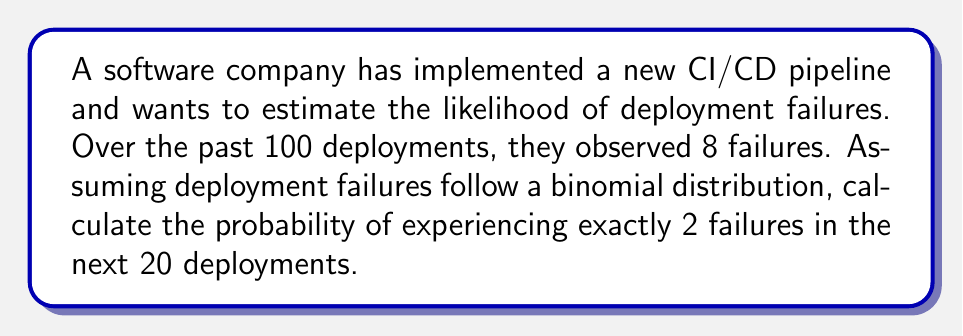Could you help me with this problem? To solve this problem, we'll use the binomial probability formula:

$$P(X = k) = \binom{n}{k} p^k (1-p)^{n-k}$$

Where:
- $n$ is the number of trials (deployments)
- $k$ is the number of successes (failures in this case)
- $p$ is the probability of success on a single trial

Step 1: Calculate the probability of failure ($p$) based on historical data
$p = \frac{\text{number of failures}}{\text{total deployments}} = \frac{8}{100} = 0.08$

Step 2: Identify the values for our scenario
- $n = 20$ (next 20 deployments)
- $k = 2$ (exactly 2 failures)
- $p = 0.08$ (calculated in step 1)

Step 3: Calculate the binomial coefficient
$$\binom{20}{2} = \frac{20!}{2!(20-2)!} = \frac{20!}{2!(18)!} = 190$$

Step 4: Apply the binomial probability formula
$$P(X = 2) = \binom{20}{2} (0.08)^2 (1-0.08)^{20-2}$$
$$= 190 \times (0.08)^2 \times (0.92)^{18}$$
$$= 190 \times 0.0064 \times 0.2217$$
$$= 0.2697$$

Step 5: Round the result to 4 decimal places
$0.2697 \approx 0.2697$
Answer: 0.2697 